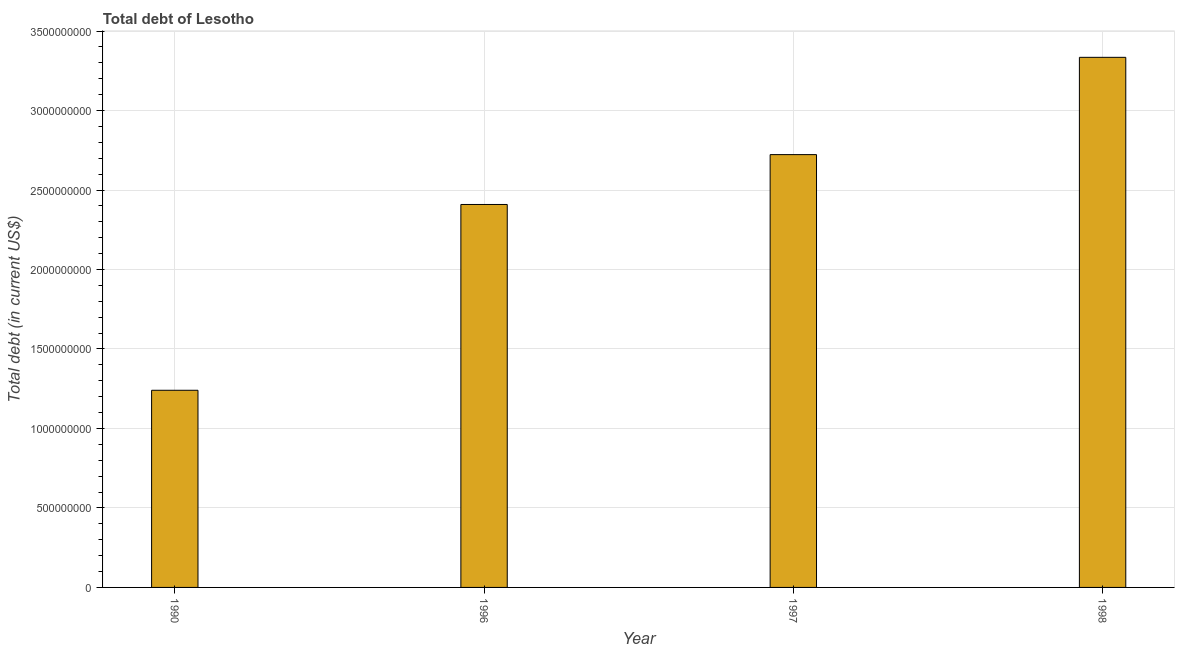Does the graph contain any zero values?
Give a very brief answer. No. What is the title of the graph?
Provide a short and direct response. Total debt of Lesotho. What is the label or title of the Y-axis?
Offer a very short reply. Total debt (in current US$). What is the total debt in 1990?
Provide a succinct answer. 1.24e+09. Across all years, what is the maximum total debt?
Offer a terse response. 3.33e+09. Across all years, what is the minimum total debt?
Provide a succinct answer. 1.24e+09. What is the sum of the total debt?
Make the answer very short. 9.71e+09. What is the difference between the total debt in 1996 and 1997?
Keep it short and to the point. -3.14e+08. What is the average total debt per year?
Provide a succinct answer. 2.43e+09. What is the median total debt?
Provide a short and direct response. 2.57e+09. Do a majority of the years between 1998 and 1997 (inclusive) have total debt greater than 300000000 US$?
Offer a very short reply. No. What is the ratio of the total debt in 1990 to that in 1996?
Your response must be concise. 0.52. What is the difference between the highest and the second highest total debt?
Provide a succinct answer. 6.12e+08. What is the difference between the highest and the lowest total debt?
Your response must be concise. 2.09e+09. Are all the bars in the graph horizontal?
Your response must be concise. No. How many years are there in the graph?
Your response must be concise. 4. What is the difference between two consecutive major ticks on the Y-axis?
Offer a terse response. 5.00e+08. What is the Total debt (in current US$) in 1990?
Ensure brevity in your answer.  1.24e+09. What is the Total debt (in current US$) of 1996?
Provide a short and direct response. 2.41e+09. What is the Total debt (in current US$) in 1997?
Provide a succinct answer. 2.72e+09. What is the Total debt (in current US$) of 1998?
Offer a terse response. 3.33e+09. What is the difference between the Total debt (in current US$) in 1990 and 1996?
Offer a very short reply. -1.17e+09. What is the difference between the Total debt (in current US$) in 1990 and 1997?
Your answer should be very brief. -1.48e+09. What is the difference between the Total debt (in current US$) in 1990 and 1998?
Make the answer very short. -2.09e+09. What is the difference between the Total debt (in current US$) in 1996 and 1997?
Provide a short and direct response. -3.14e+08. What is the difference between the Total debt (in current US$) in 1996 and 1998?
Your response must be concise. -9.26e+08. What is the difference between the Total debt (in current US$) in 1997 and 1998?
Ensure brevity in your answer.  -6.12e+08. What is the ratio of the Total debt (in current US$) in 1990 to that in 1996?
Your response must be concise. 0.52. What is the ratio of the Total debt (in current US$) in 1990 to that in 1997?
Make the answer very short. 0.46. What is the ratio of the Total debt (in current US$) in 1990 to that in 1998?
Keep it short and to the point. 0.37. What is the ratio of the Total debt (in current US$) in 1996 to that in 1997?
Your response must be concise. 0.89. What is the ratio of the Total debt (in current US$) in 1996 to that in 1998?
Provide a succinct answer. 0.72. What is the ratio of the Total debt (in current US$) in 1997 to that in 1998?
Your response must be concise. 0.82. 